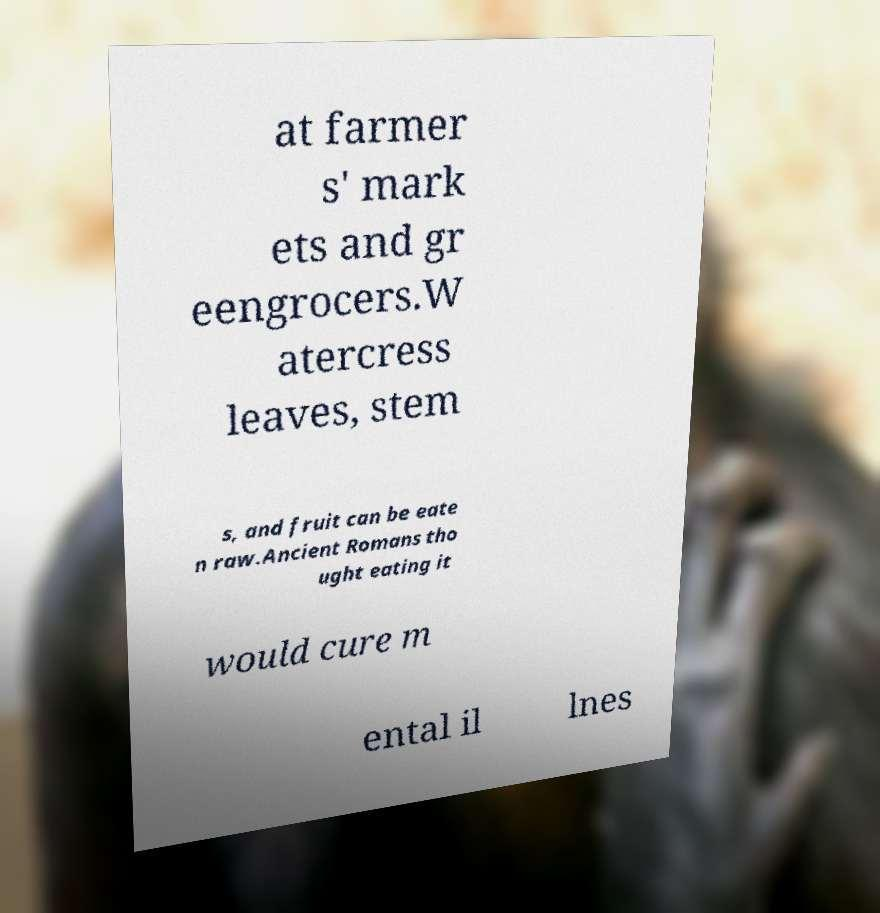Could you extract and type out the text from this image? at farmer s' mark ets and gr eengrocers.W atercress leaves, stem s, and fruit can be eate n raw.Ancient Romans tho ught eating it would cure m ental il lnes 